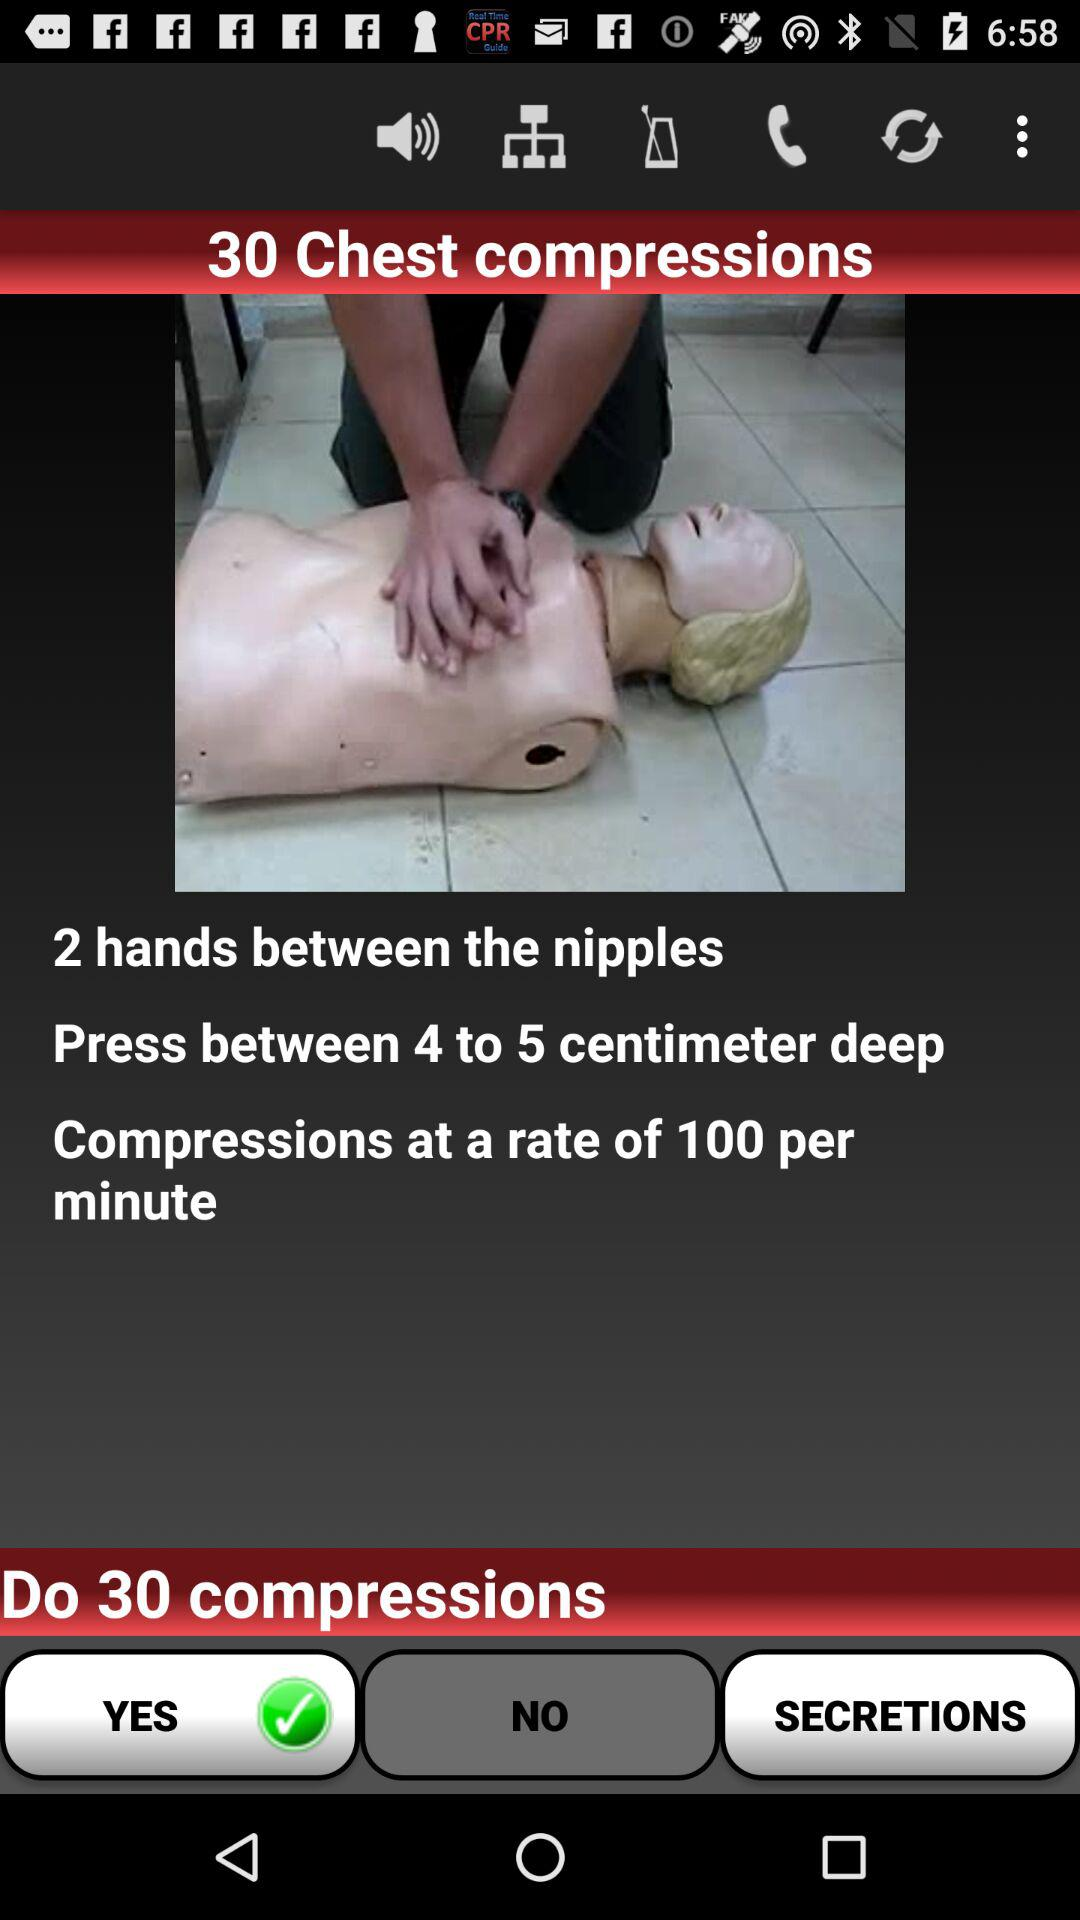How many times do you have to do chest compressions?
Answer the question using a single word or phrase. 30 